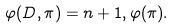Convert formula to latex. <formula><loc_0><loc_0><loc_500><loc_500>\varphi ( D , \pi ) = n + 1 , \varphi ( \pi ) .</formula> 